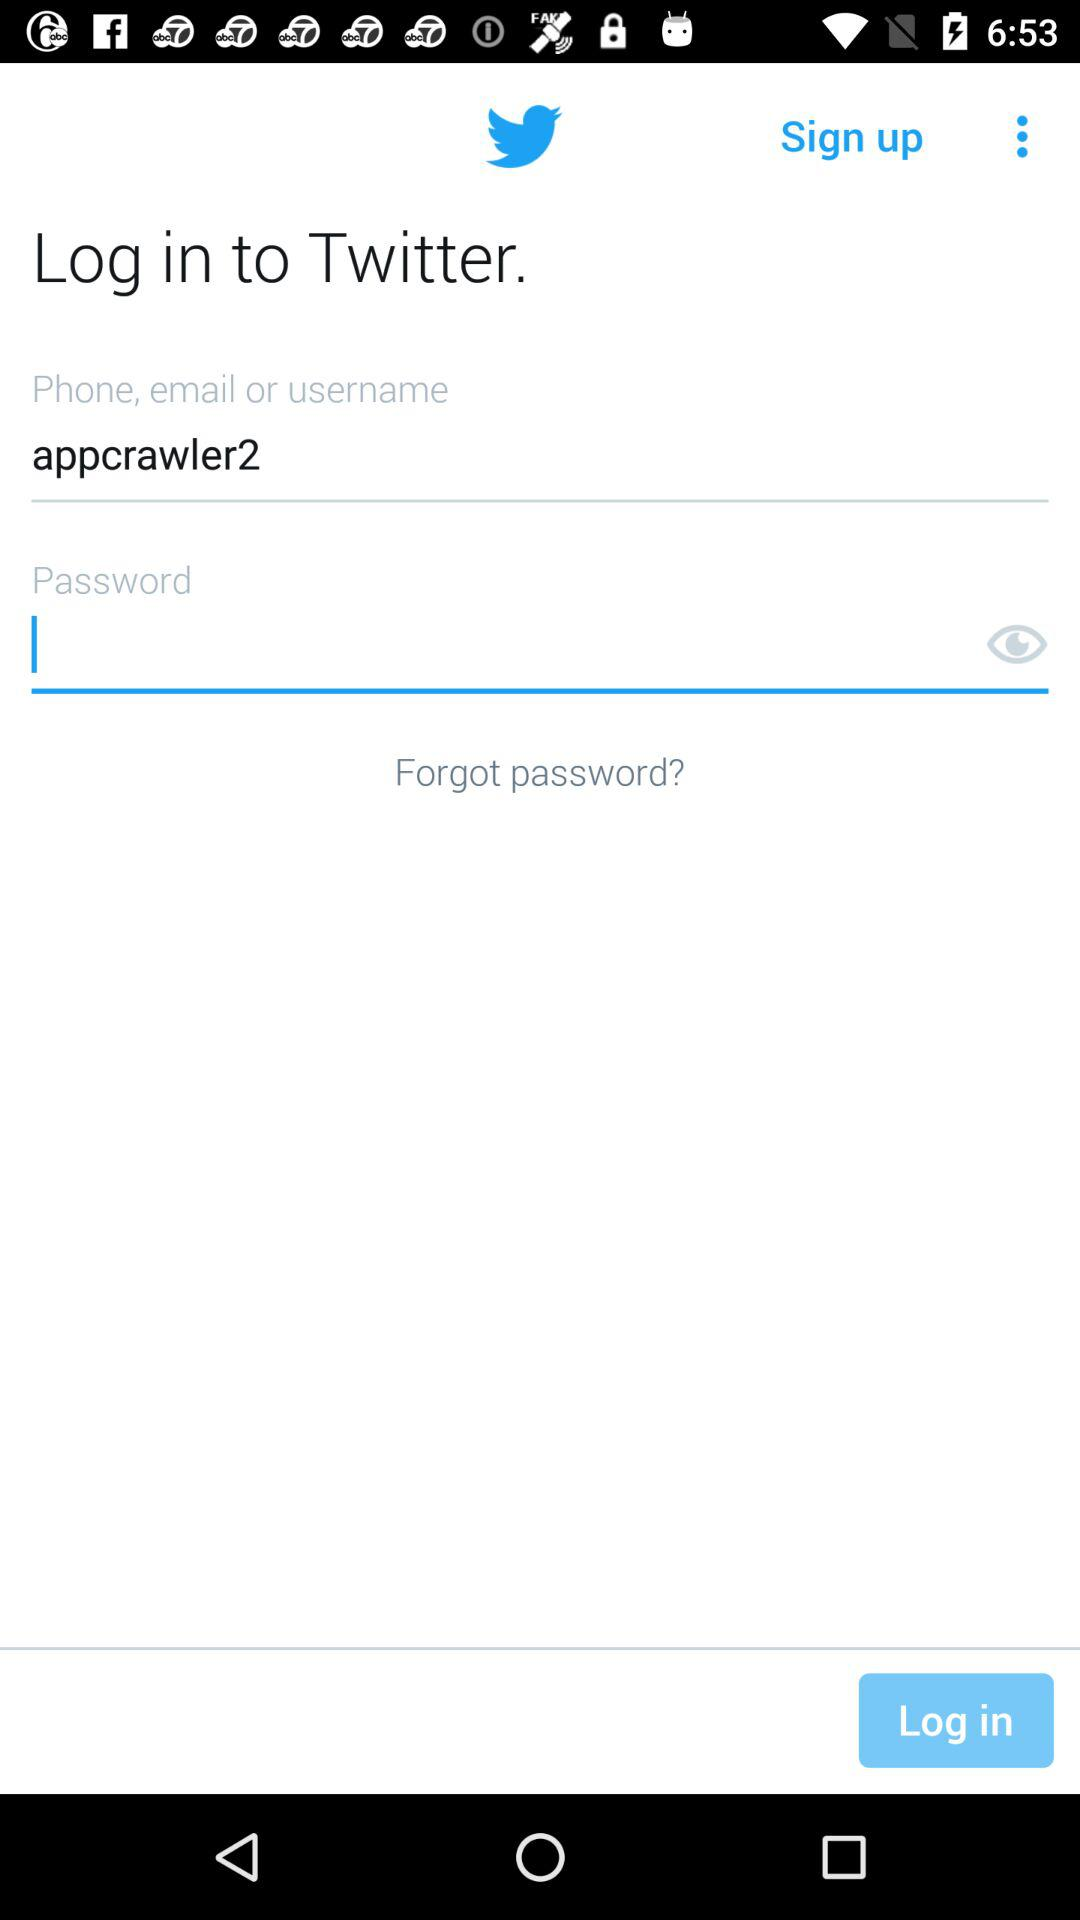What is the application name? The application name is "Twitter". 